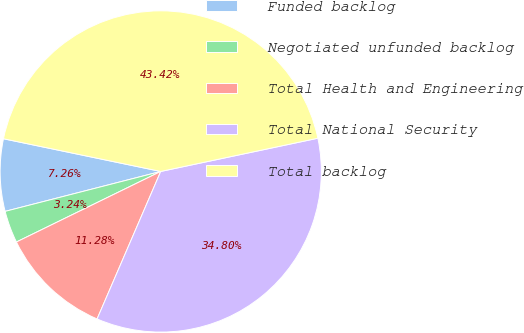Convert chart to OTSL. <chart><loc_0><loc_0><loc_500><loc_500><pie_chart><fcel>Funded backlog<fcel>Negotiated unfunded backlog<fcel>Total Health and Engineering<fcel>Total National Security<fcel>Total backlog<nl><fcel>7.26%<fcel>3.24%<fcel>11.28%<fcel>34.8%<fcel>43.42%<nl></chart> 